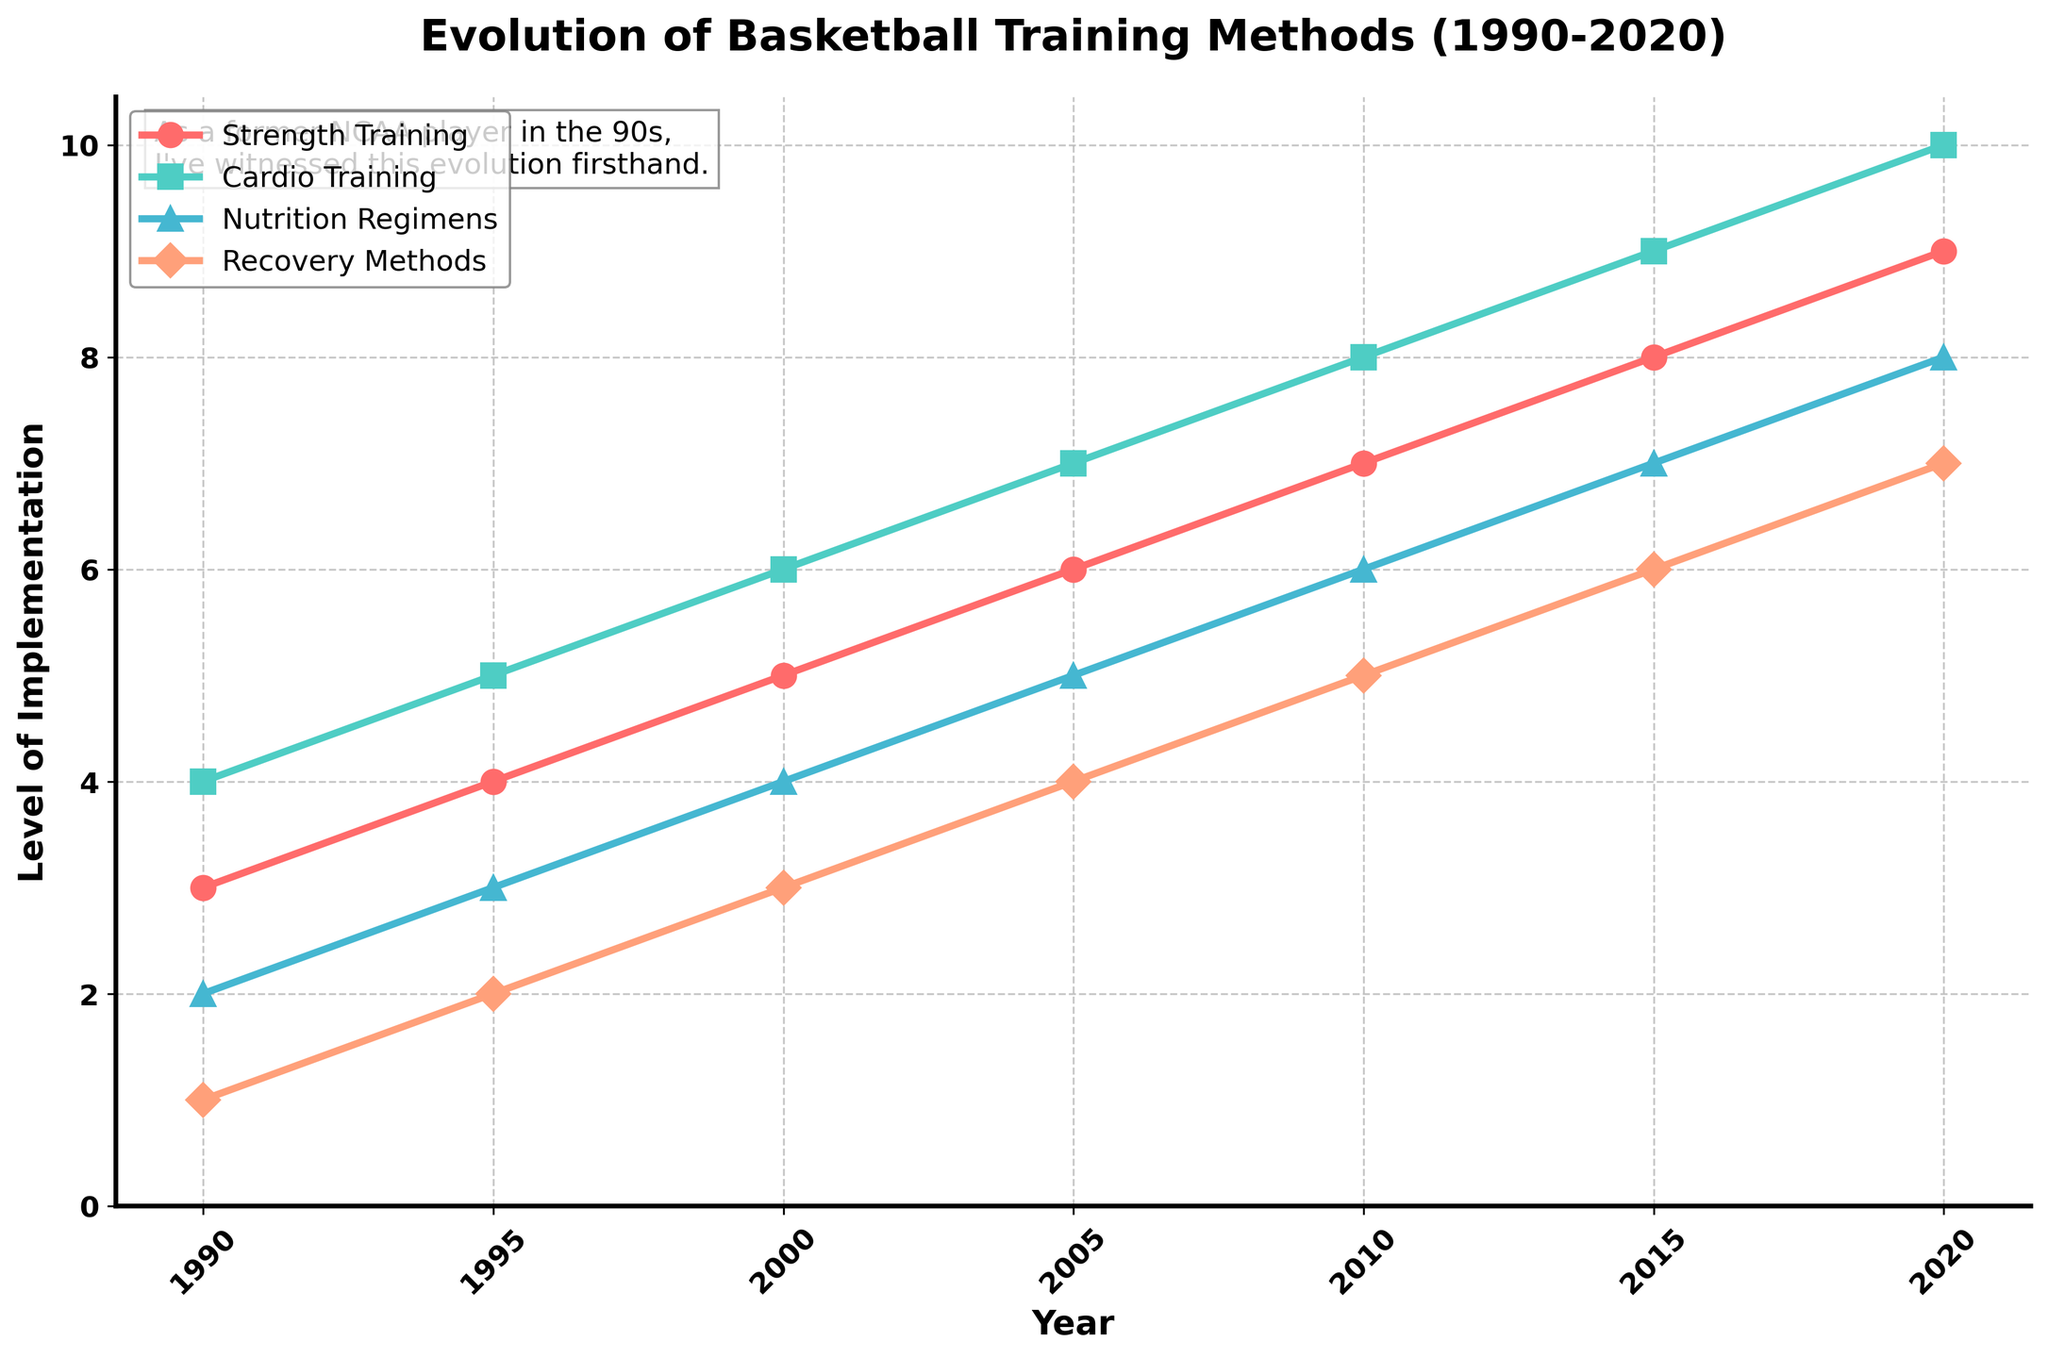What's the title of the figure? The title of a figure is usually placed at the top, providing a brief description of what the figure represents. In the provided time series plot, the title is "Evolution of Basketball Training Methods (1990-2020)" as it describes the changes in various training methods over this period.
Answer: Evolution of Basketball Training Methods (1990-2020) Which training method had the lowest level of implementation in 1990? By looking at the 1990 data points for each training method, we observe that "recovery methods" has the lowest value of 1 compared to the others (strength training: 3, cardio training: 4, nutrition regimens: 2).
Answer: Recovery methods What was the most implemented training method in 2020? The highest value in 2020 can be identified by checking the values for each method in that year. "Cardio training" shows the highest implementation with a value of 10.
Answer: Cardio training How many different training methods are tracked in the figure? By examining the legend, which lists all the training methods depicted in the plot, we count a total of four different categories: strength training, cardio training, nutrition regimens, and recovery methods.
Answer: Four By how much did the level of recovery methods increase from 1990 to 2000? Take the value of recovery methods in 2000 (3) and subtract the value in 1990 (1). The increase is calculated as 3 - 1 = 2.
Answer: 2 Which training methods had continuous growth in the level of implementation from 1990 to 2020? Observing the trajectory of each method across the years, we note that all methods (strength training, cardio training, nutrition regimens, and recovery methods) show a steady increase without any decline for the duration.
Answer: All methods What was the average level of strength training implementation in the years 2000, 2005, and 2010? First, add the values of strength training in each of the years (5 in 2000, 6 in 2005, 7 in 2010). The sum is 5 + 6 + 7 = 18. Then, calculate the average by dividing by the number of years: 18 / 3 = 6.
Answer: 6 In which years did the implementation level of nutrition regimens surpass that of strength training? Check each year where the value for nutrition regimens is greater than that for strength training. This first occurs in 2000 when the value for nutrition regimens (4) matches strength training (5) but subsequently surpasses it in 2005 (nutrition: 5, strength: 6), 2010 (nutrition: 6, strength: 7), 2015 (nutrition: 7, strength: 8), and 2020 (nutrition: 8, strength: 9).
Answer: None 